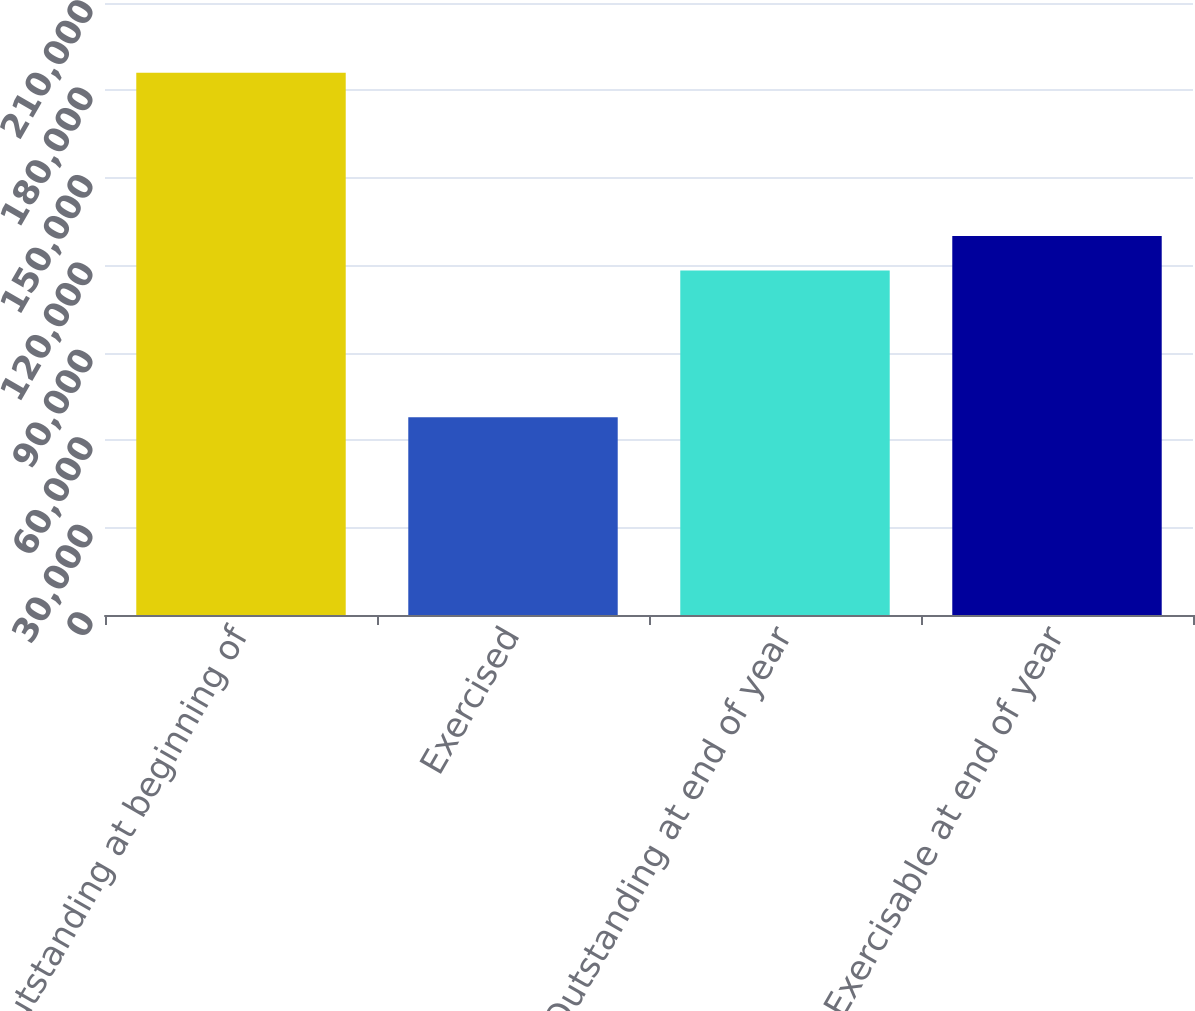Convert chart. <chart><loc_0><loc_0><loc_500><loc_500><bar_chart><fcel>Outstanding at beginning of<fcel>Exercised<fcel>Outstanding at end of year<fcel>Exercisable at end of year<nl><fcel>186054<fcel>67829<fcel>118225<fcel>130048<nl></chart> 